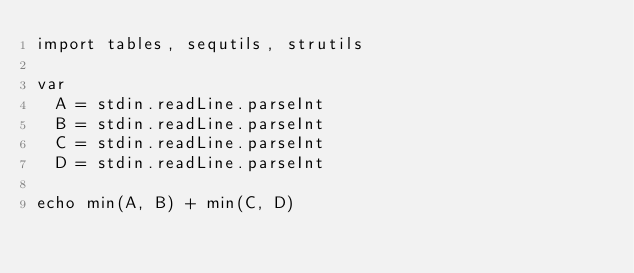Convert code to text. <code><loc_0><loc_0><loc_500><loc_500><_Nim_>import tables, sequtils, strutils

var
  A = stdin.readLine.parseInt
  B = stdin.readLine.parseInt
  C = stdin.readLine.parseInt
  D = stdin.readLine.parseInt

echo min(A, B) + min(C, D)</code> 